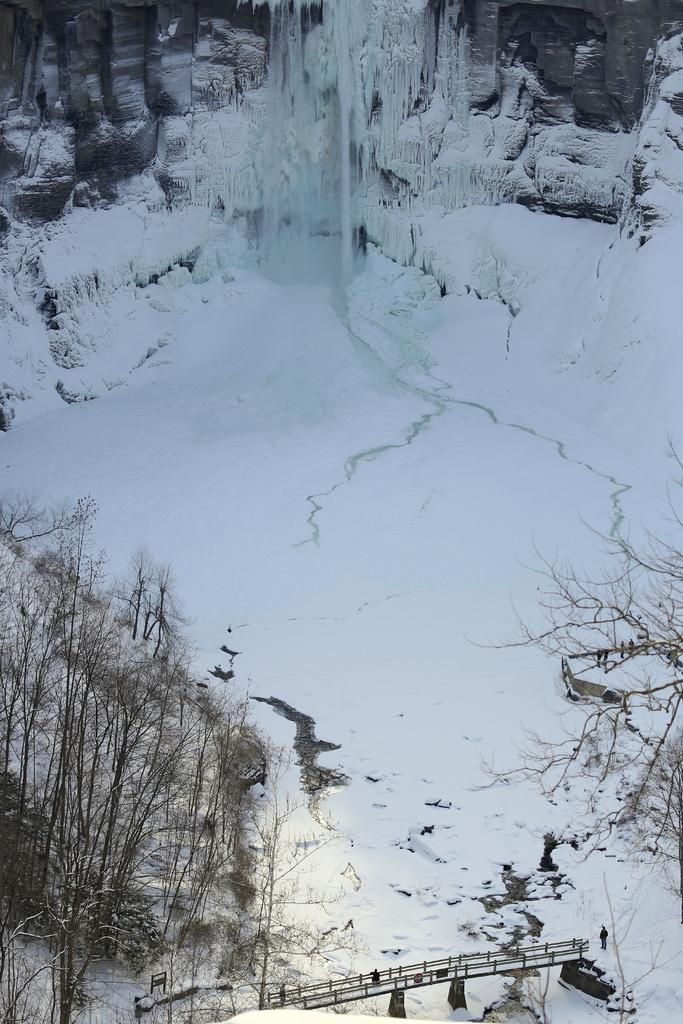What type of vegetation can be seen in the image? There are trees in the image. What is the weather like in the image? There is snow visible in the image, indicating a cold and likely snowy environment. What type of structure is present in the image? There is a bridge in the image. Can you tell me how many flights are taking off from the bridge in the image? There are no flights or airplanes present in the image; it features trees, snow, and a bridge. How many men are visible on the bridge in the image? There are no men visible in the image; it only shows trees, snow, and the bridge itself. 